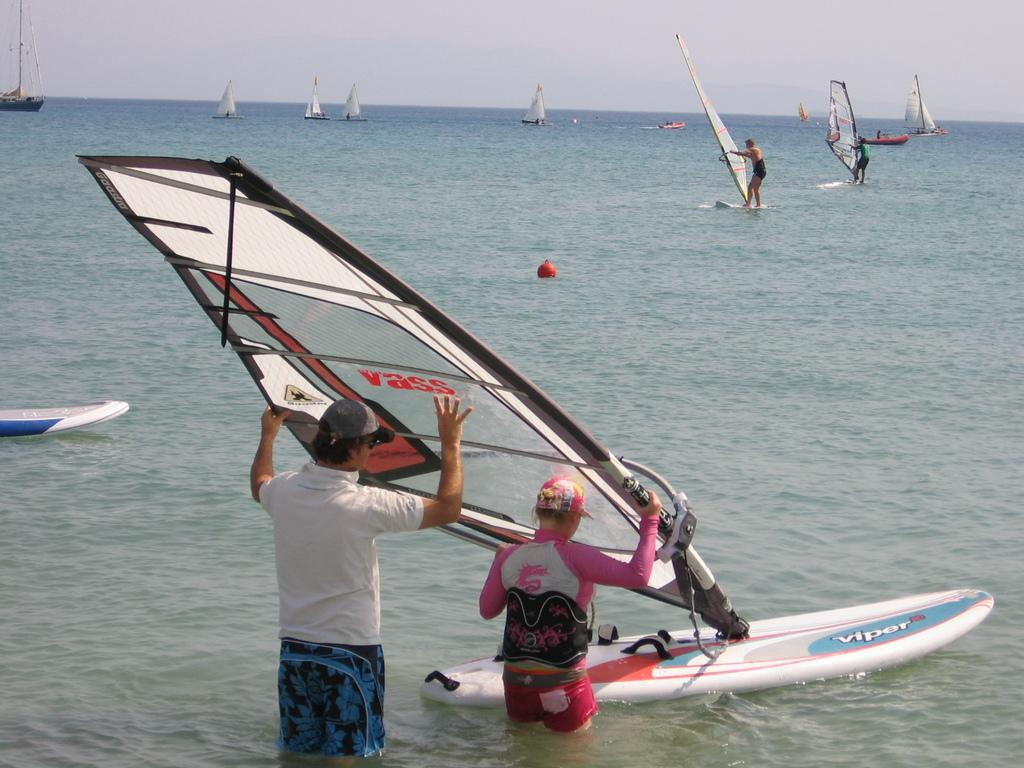What are the two people holding in the image? They are holding a mast in the image. What are they using the mast for? They are using a surfing board with the mast. What activity are many people engaged in on the water body? Many people are doing windsurfing on a water body. What other type of watercraft is visible in the image? There is a boat in the image. What is the condition of the sky in the image? The sky is cloudy in the image. Reasoning: Let' Let's think step by step in order to produce the conversation. We start by identifying the main subjects and objects in the image based on the provided facts. We then formulate questions that focus on the location and characteristics of these subjects and objects, ensuring that each question can be answered definitively with the information given. We avoid yes/no questions and ensure that the language is simple and clear. Absurd Question/Answer: How many cakes are being used for windsurfing in the image? There are no cakes present in the image; people are windsurfing using surfing boards. What part of the brain can be seen in the image? There is no brain visible in the image; it features people windsurfing and a boat on a water body. How many feathers are being used as sails for the windsurfing boards in the image? There are no feathers present in the image; people are windsurfing using surfing boards with masts and sails. 